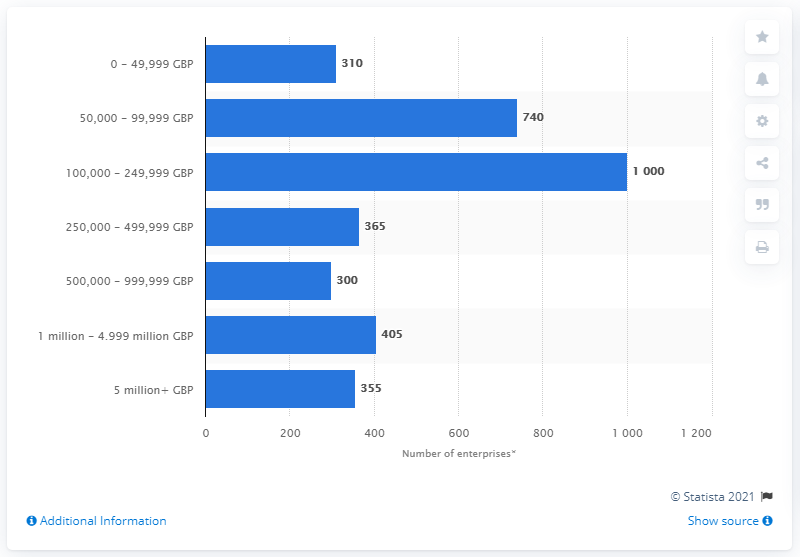Highlight a few significant elements in this photo. As of March 2020, it was reported that 355 enterprises in the motor vehicles, trailers and semi-trailers industry had a turnover of more than 5 million GBP. 